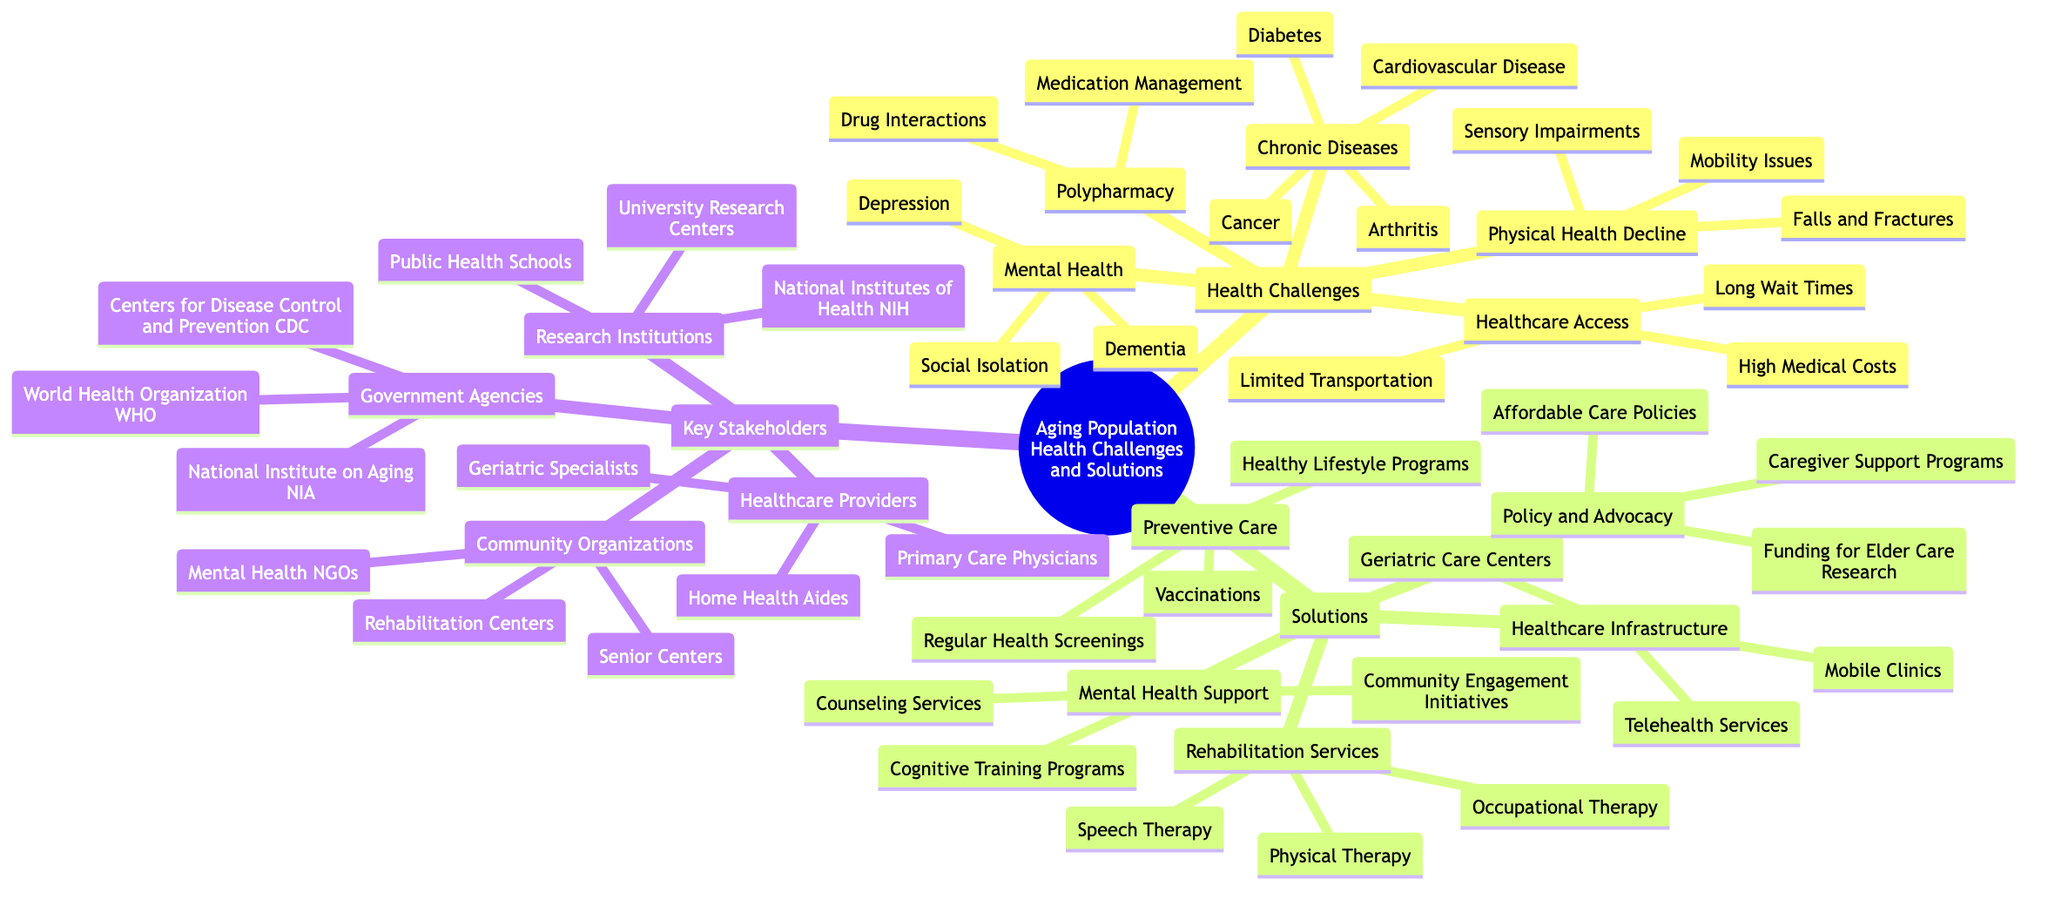What are the three main topics in the mind map? The mind map branches into three main topics: Health Challenges, Solutions, and Key Stakeholders.
Answer: Health Challenges, Solutions, Key Stakeholders How many chronic diseases are listed in the diagram? Under the Health Challenges branch, there are four chronic diseases: Cardiovascular Disease, Diabetes, Cancer, and Arthritis.
Answer: 4 What kind of support is included under Mental Health Support? Mental Health Support includes three types: Cognitive Training Programs, Counseling Services, and Community Engagement Initiatives.
Answer: Cognitive Training Programs, Counseling Services, Community Engagement Initiatives Which stakeholder group has "Home Health Aides" listed? "Home Health Aides" is a part of the Healthcare Providers group under Key Stakeholders.
Answer: Healthcare Providers What is one solution for addressing physical health decline? One solution for physical health decline is Physical Therapy, which is listed under Rehabilitation Services in the Solutions branch.
Answer: Physical Therapy Which funding focus is mentioned in the Policy and Advocacy section? The Policy and Advocacy section mentions Funding for Elder Care Research as one of its focuses.
Answer: Funding for Elder Care Research Count the number of healthcare access challenges. There are three healthcare access challenges listed: Long Wait Times, Limited Transportation, and High Medical Costs, making a total of three.
Answer: 3 How many types of preventive care are included? The Preventive Care solutions include three types: Regular Health Screenings, Vaccinations, and Healthy Lifestyle Programs, totaling three.
Answer: 3 Name one agency listed under Government Agencies. One agency listed is the Centers for Disease Control and Prevention (CDC) under the Government Agencies section.
Answer: Centers for Disease Control and Prevention (CDC) 